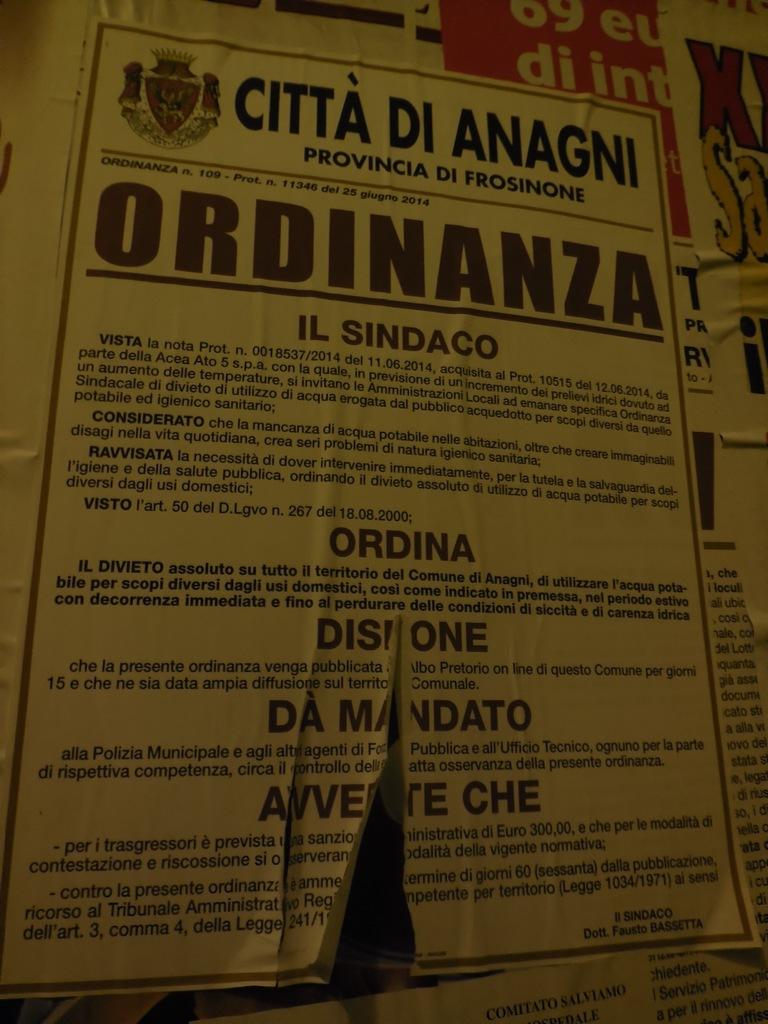What is written in the largest bold letters?
Offer a terse response. Ordinanza. 